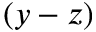Convert formula to latex. <formula><loc_0><loc_0><loc_500><loc_500>( y - z )</formula> 